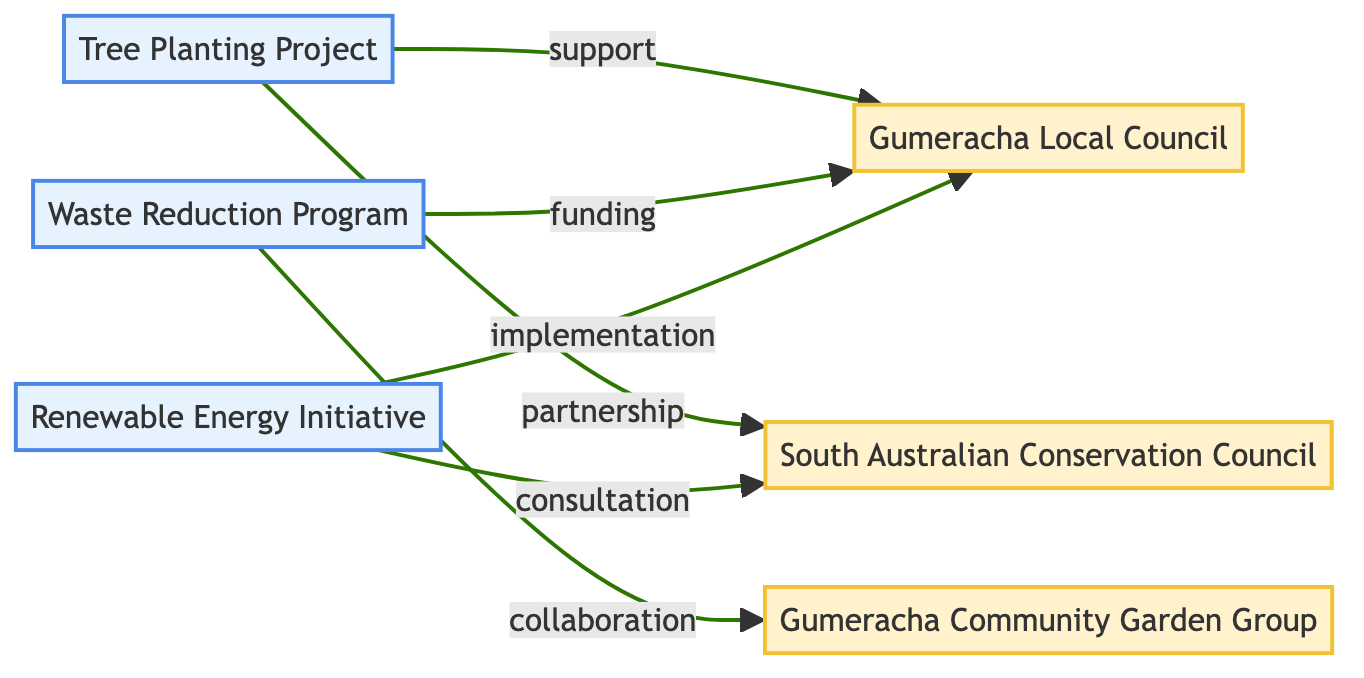What is the total number of projects depicted in the diagram? The diagram lists three distinct projects under the "nodes" section: the Tree Planting Project, the Waste Reduction Program, and the Renewable Energy Initiative. Therefore, by counting them, we find there are three projects total.
Answer: 3 Which stakeholder is involved in the Tree Planting Project? Upon examining the edges related to the Tree Planting Project, it shows connections to Gumeracha Local Council (support) and South Australian Conservation Council (partnership). Thus, both stakeholders are involved, but Gumeracha Local Council is the specific government body connected directly.
Answer: Gumeracha Local Council How many connections are shown for the Waste Reduction Program? The Waste Reduction Program has two edges: one connecting to the Gumeracha Local Council (funding) and another to the Gumeracha Community Garden Group (collaboration). Counting these edges gives a total of two connections for this project.
Answer: 2 What type of relationship exists between the Renewable Energy Initiative and the South Australian Conservation Council? The diagram indicates a connection between the Renewable Energy Initiative and the South Australian Conservation Council with the label "consultation." This describes the type of relationship in question.
Answer: consultation Which project does the Gumeracha Community Garden Group collaborate on? The only edge in the diagram that connects the Gumeracha Community Garden Group is with the Waste Reduction Program, indicating their collaboration. Thus, it specifically refers to this project.
Answer: Waste Reduction Program How many stakeholders are listed in the diagram? The diagram identifies three unique stakeholders: Gumeracha Local Council, South Australian Conservation Council, and Gumeracha Community Garden Group. Counting these entities reveals a total of three stakeholders.
Answer: 3 Which stakeholders are involved in the Tree Planting Project? The Tree Planting Project has edges connecting to two different stakeholders: Gumeracha Local Council (as support) and South Australian Conservation Council (as a partner). Therefore, both stakeholders are involved in this project.
Answer: Gumeracha Local Council and South Australian Conservation Council What is the nature of the connection between the Gumeracha Local Council and the Renewable Energy Initiative? The connection is labeled "implementation," indicating that this is the nature of the interaction or support provided by the Gumeracha Local Council towards the Renewable Energy Initiative.
Answer: implementation 